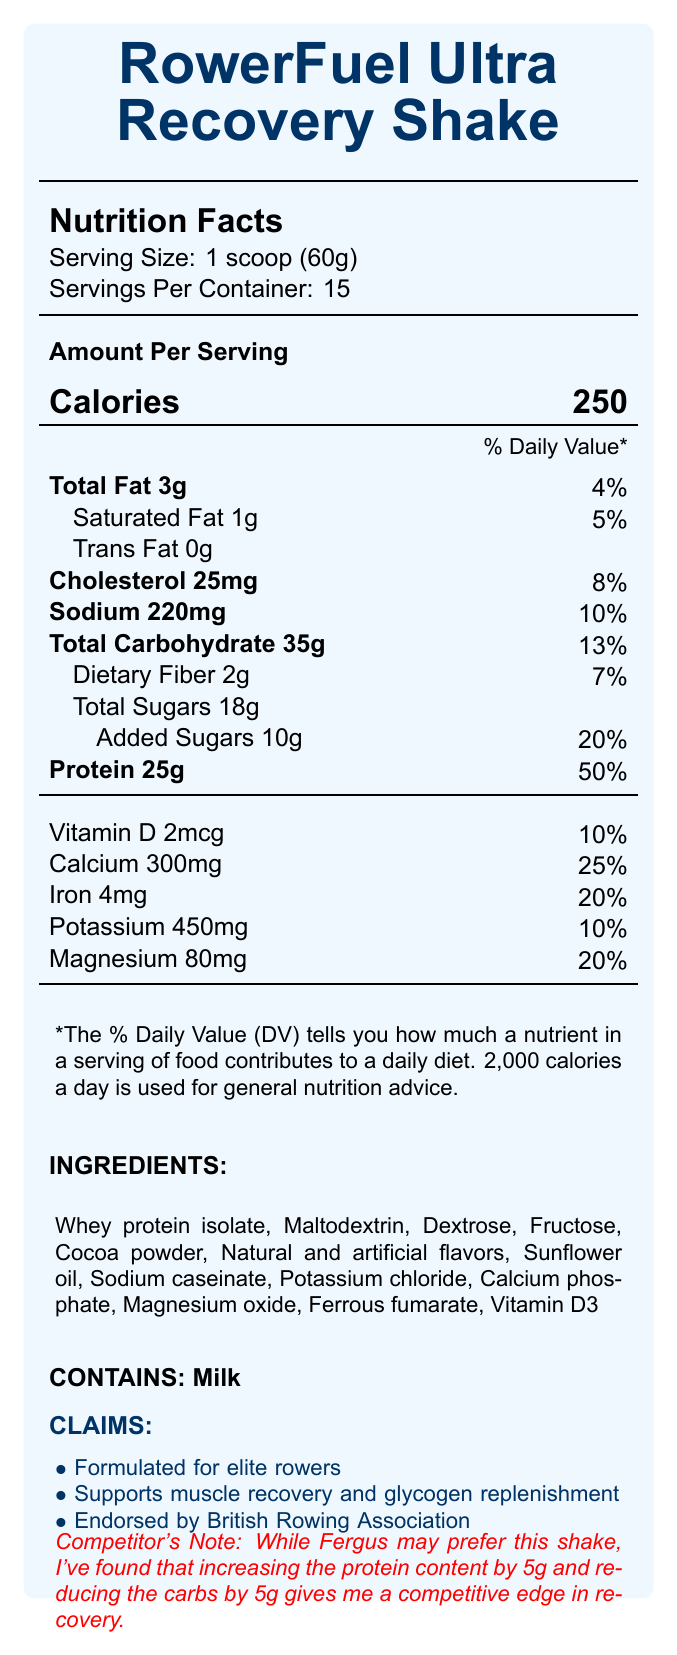what is the serving size for the RowerFuel Ultra Recovery Shake? According to the document, the serving size is listed as "1 scoop (60g)".
Answer: 1 scoop (60g) how many servings are there per container of the product? The document specifies that there are 15 servings per container.
Answer: 15 how much calcium is in one serving? The calcium content per serving is listed as 300mg.
Answer: 300mg what is the amount of added sugars per serving? The document mentions "Added Sugars 10g".
Answer: 10g what percentage of the Daily Value of protein does one serving provide? The nutrition facts show that the protein content per serving is 25g, which is 50% of the Daily Value.
Answer: 50% which nutrient contributes 10% of the Daily Value? The document specifies that Vitamin D (2mcg), Sodium (220mg), and Potassium (450mg) each contribute 10% of the Daily Value.
Answer: Vitamin D or Sodium or Potassium how many grams of total carbohydrate are in one serving? The document states that there are 35g of total carbohydrate per serving.
Answer: 35g does this product contain any trans fat? The document explicitly lists Trans Fat as "0g".
Answer: No which claim is NOT listed on the document? A. Contains antioxidants B. Supports muscle recovery C. Endorsed by British Rowing Association The document lists "Supports muscle recovery and glycogen replenishment" and "Endorsed by British Rowing Association" but does not mention antioxidants.
Answer: A. Contains antioxidants what is the amount of cholesterol in one serving? The cholesterol content per serving is given as 25mg.
Answer: 25mg which of the following ingredients is used in the product? A. Stevia B. Sunflower oil C. Soy Protein The document lists Sunflower oil as one of the ingredients but does not mention Stevia or Soy Protein.
Answer: B. Sunflower oil is the product suitable for those with dairy allergies? The allergens section clearly states “Contains milk”.
Answer: No how many grams of saturated fat are present per serving? The saturated fat content per serving is listed as 1g.
Answer: 1g summarize the main idea of the document. The summary includes key nutritional information, purpose, and endorsement related to the product.
Answer: The document provides the nutritional facts and ingredients for the RowerFuel Ultra Recovery Shake, a meal replacement shake formulated for elite rowers. The shake contains 250 calories per serving, 25g of protein, and is endorsed by the British Rowing Association. It is designed to support muscle recovery and glycogen replenishment. how does the competitor suggest modifying the shake for a competitive edge? The competitor's note states that increasing protein by 5g and reducing carbs by 5g gives a competitive edge.
Answer: Increasing the protein content by 5g and reducing the carbs by 5g how many grams of dietary fiber are present in one serving? The nutrition facts indicate there are 2g of dietary fiber per serving.
Answer: 2g what is the color of the text used for the product's name on the document? The document uses the color rowing blue for the product's name.
Answer: Rowing blue does the shake contain any artificial flavors? Artificial flavors are listed in the ingredients.
Answer: Yes what is the amount of Vitamin D in one serving? The Vitamin D content per serving is given as 2mcg.
Answer: 2mcg does the document specify the manufacturing country of the RowerFuel Ultra Recovery Shake? The document does not provide any information about the manufacturing country.
Answer: Not enough information 